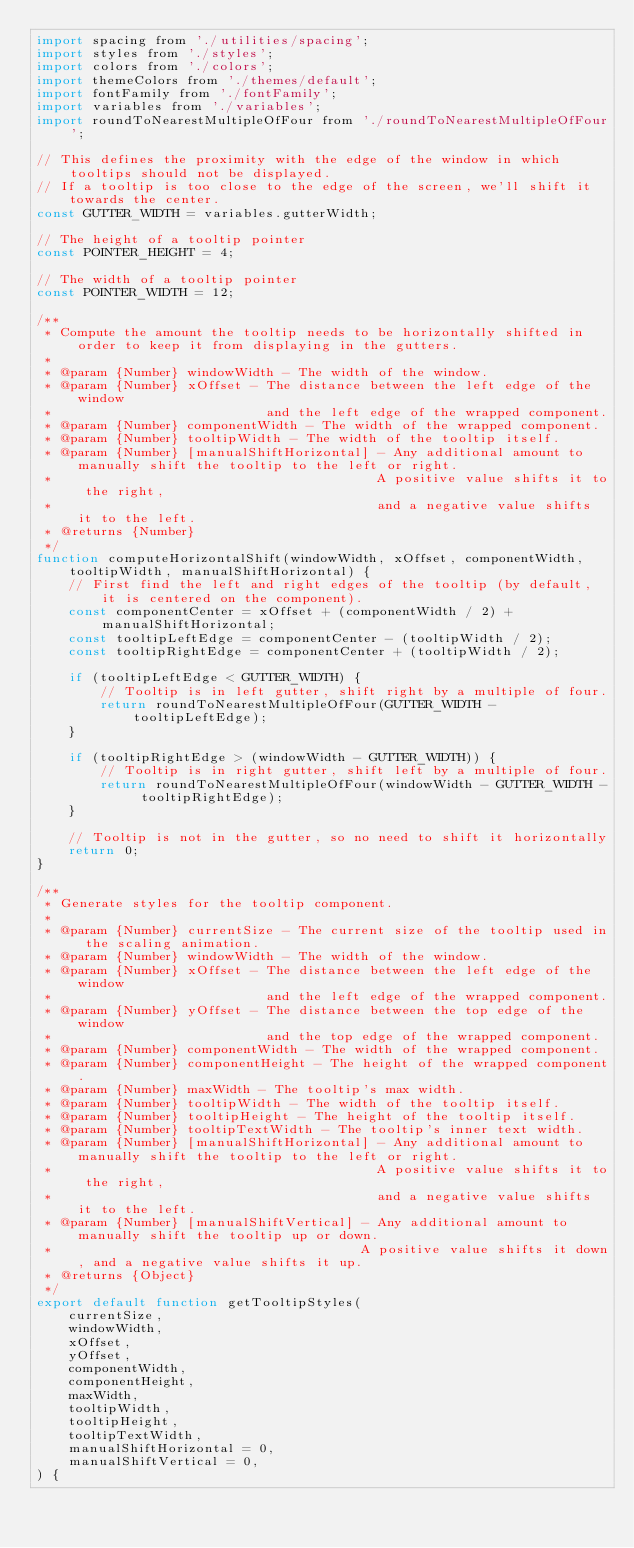<code> <loc_0><loc_0><loc_500><loc_500><_JavaScript_>import spacing from './utilities/spacing';
import styles from './styles';
import colors from './colors';
import themeColors from './themes/default';
import fontFamily from './fontFamily';
import variables from './variables';
import roundToNearestMultipleOfFour from './roundToNearestMultipleOfFour';

// This defines the proximity with the edge of the window in which tooltips should not be displayed.
// If a tooltip is too close to the edge of the screen, we'll shift it towards the center.
const GUTTER_WIDTH = variables.gutterWidth;

// The height of a tooltip pointer
const POINTER_HEIGHT = 4;

// The width of a tooltip pointer
const POINTER_WIDTH = 12;

/**
 * Compute the amount the tooltip needs to be horizontally shifted in order to keep it from displaying in the gutters.
 *
 * @param {Number} windowWidth - The width of the window.
 * @param {Number} xOffset - The distance between the left edge of the window
 *                           and the left edge of the wrapped component.
 * @param {Number} componentWidth - The width of the wrapped component.
 * @param {Number} tooltipWidth - The width of the tooltip itself.
 * @param {Number} [manualShiftHorizontal] - Any additional amount to manually shift the tooltip to the left or right.
 *                                         A positive value shifts it to the right,
 *                                         and a negative value shifts it to the left.
 * @returns {Number}
 */
function computeHorizontalShift(windowWidth, xOffset, componentWidth, tooltipWidth, manualShiftHorizontal) {
    // First find the left and right edges of the tooltip (by default, it is centered on the component).
    const componentCenter = xOffset + (componentWidth / 2) + manualShiftHorizontal;
    const tooltipLeftEdge = componentCenter - (tooltipWidth / 2);
    const tooltipRightEdge = componentCenter + (tooltipWidth / 2);

    if (tooltipLeftEdge < GUTTER_WIDTH) {
        // Tooltip is in left gutter, shift right by a multiple of four.
        return roundToNearestMultipleOfFour(GUTTER_WIDTH - tooltipLeftEdge);
    }

    if (tooltipRightEdge > (windowWidth - GUTTER_WIDTH)) {
        // Tooltip is in right gutter, shift left by a multiple of four.
        return roundToNearestMultipleOfFour(windowWidth - GUTTER_WIDTH - tooltipRightEdge);
    }

    // Tooltip is not in the gutter, so no need to shift it horizontally
    return 0;
}

/**
 * Generate styles for the tooltip component.
 *
 * @param {Number} currentSize - The current size of the tooltip used in the scaling animation.
 * @param {Number} windowWidth - The width of the window.
 * @param {Number} xOffset - The distance between the left edge of the window
 *                           and the left edge of the wrapped component.
 * @param {Number} yOffset - The distance between the top edge of the window
 *                           and the top edge of the wrapped component.
 * @param {Number} componentWidth - The width of the wrapped component.
 * @param {Number} componentHeight - The height of the wrapped component.
 * @param {Number} maxWidth - The tooltip's max width.
 * @param {Number} tooltipWidth - The width of the tooltip itself.
 * @param {Number} tooltipHeight - The height of the tooltip itself.
 * @param {Number} tooltipTextWidth - The tooltip's inner text width.
 * @param {Number} [manualShiftHorizontal] - Any additional amount to manually shift the tooltip to the left or right.
 *                                         A positive value shifts it to the right,
 *                                         and a negative value shifts it to the left.
 * @param {Number} [manualShiftVertical] - Any additional amount to manually shift the tooltip up or down.
 *                                       A positive value shifts it down, and a negative value shifts it up.
 * @returns {Object}
 */
export default function getTooltipStyles(
    currentSize,
    windowWidth,
    xOffset,
    yOffset,
    componentWidth,
    componentHeight,
    maxWidth,
    tooltipWidth,
    tooltipHeight,
    tooltipTextWidth,
    manualShiftHorizontal = 0,
    manualShiftVertical = 0,
) {</code> 